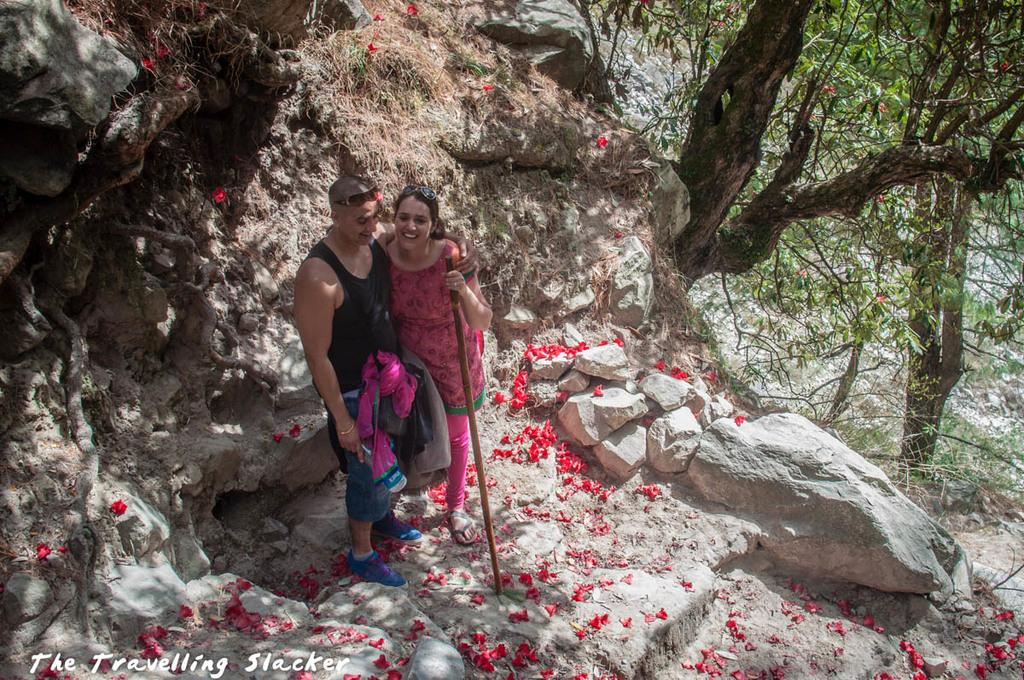How many people are in the image? There are two people in the image. What are the people doing in the image? The people are standing in the image. What are the people wearing? The people are wearing different color dresses. What are the people holding in the image? The people are holding sticks in the image. What can be seen in the background of the image? There are trees, red color flowers, and a rock in the background of the image. What type of prose is being recited by the people in the image? There is no indication in the image that the people are reciting any prose. 